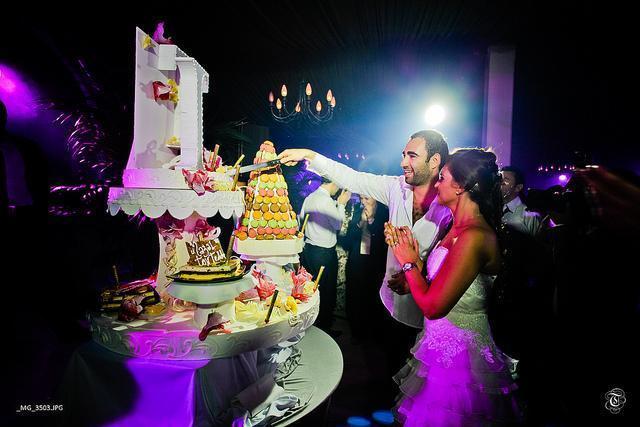How many people are in the picture?
Give a very brief answer. 4. How many cakes can be seen?
Give a very brief answer. 3. 